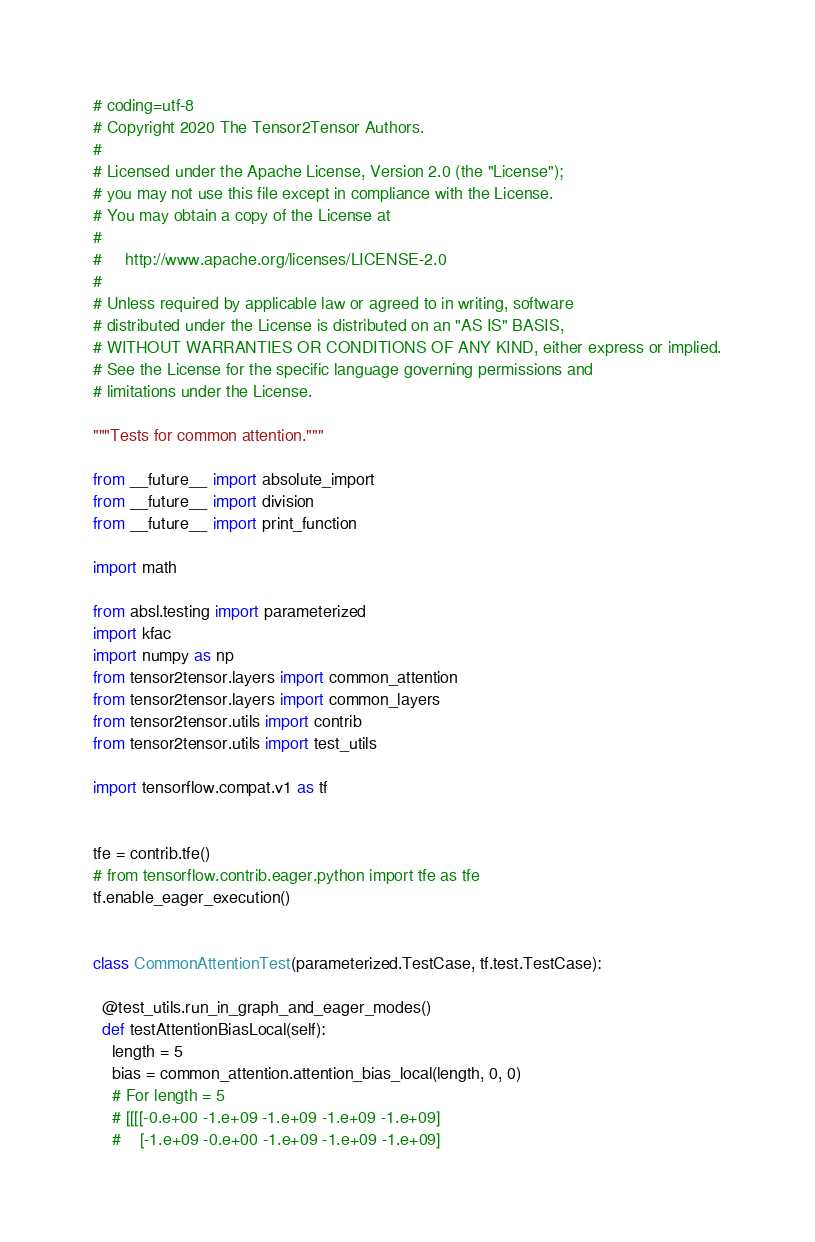<code> <loc_0><loc_0><loc_500><loc_500><_Python_># coding=utf-8
# Copyright 2020 The Tensor2Tensor Authors.
#
# Licensed under the Apache License, Version 2.0 (the "License");
# you may not use this file except in compliance with the License.
# You may obtain a copy of the License at
#
#     http://www.apache.org/licenses/LICENSE-2.0
#
# Unless required by applicable law or agreed to in writing, software
# distributed under the License is distributed on an "AS IS" BASIS,
# WITHOUT WARRANTIES OR CONDITIONS OF ANY KIND, either express or implied.
# See the License for the specific language governing permissions and
# limitations under the License.

"""Tests for common attention."""

from __future__ import absolute_import
from __future__ import division
from __future__ import print_function

import math

from absl.testing import parameterized
import kfac
import numpy as np
from tensor2tensor.layers import common_attention
from tensor2tensor.layers import common_layers
from tensor2tensor.utils import contrib
from tensor2tensor.utils import test_utils

import tensorflow.compat.v1 as tf


tfe = contrib.tfe()
# from tensorflow.contrib.eager.python import tfe as tfe
tf.enable_eager_execution()


class CommonAttentionTest(parameterized.TestCase, tf.test.TestCase):

  @test_utils.run_in_graph_and_eager_modes()
  def testAttentionBiasLocal(self):
    length = 5
    bias = common_attention.attention_bias_local(length, 0, 0)
    # For length = 5
    # [[[[-0.e+00 -1.e+09 -1.e+09 -1.e+09 -1.e+09]
    #    [-1.e+09 -0.e+00 -1.e+09 -1.e+09 -1.e+09]</code> 